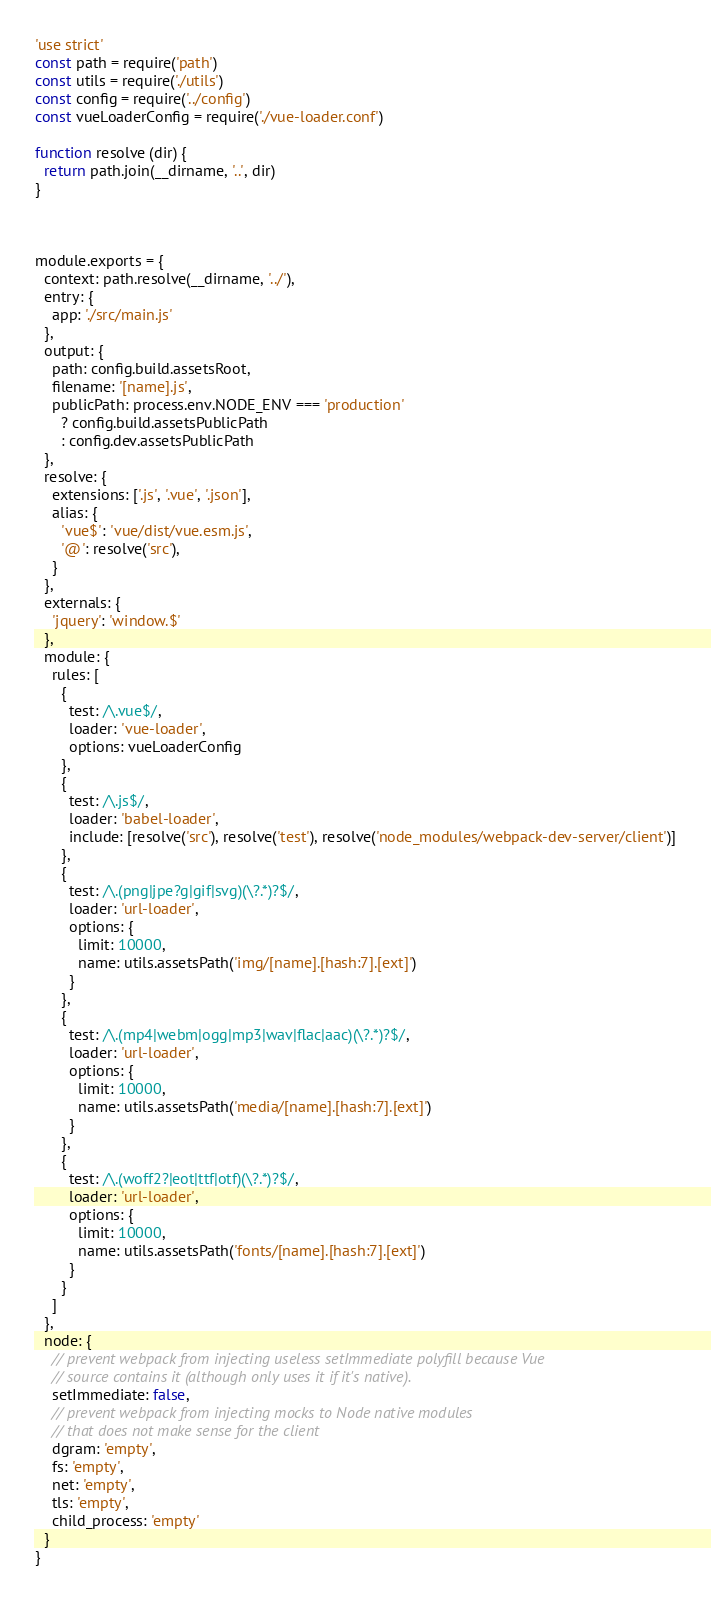Convert code to text. <code><loc_0><loc_0><loc_500><loc_500><_JavaScript_>'use strict'
const path = require('path')
const utils = require('./utils')
const config = require('../config')
const vueLoaderConfig = require('./vue-loader.conf')

function resolve (dir) {
  return path.join(__dirname, '..', dir)
}



module.exports = {
  context: path.resolve(__dirname, '../'),
  entry: {
    app: './src/main.js'
  },
  output: {
    path: config.build.assetsRoot,
    filename: '[name].js',
    publicPath: process.env.NODE_ENV === 'production'
      ? config.build.assetsPublicPath
      : config.dev.assetsPublicPath
  },
  resolve: {
    extensions: ['.js', '.vue', '.json'],
    alias: {
      'vue$': 'vue/dist/vue.esm.js',
      '@': resolve('src'),
    }
  },
  externals: {
    'jquery': 'window.$'
  },
  module: {
    rules: [
      {
        test: /\.vue$/,
        loader: 'vue-loader',
        options: vueLoaderConfig
      },
      {
        test: /\.js$/,
        loader: 'babel-loader',
        include: [resolve('src'), resolve('test'), resolve('node_modules/webpack-dev-server/client')]
      },
      {
        test: /\.(png|jpe?g|gif|svg)(\?.*)?$/,
        loader: 'url-loader',
        options: {
          limit: 10000,
          name: utils.assetsPath('img/[name].[hash:7].[ext]')
        }
      },
      {
        test: /\.(mp4|webm|ogg|mp3|wav|flac|aac)(\?.*)?$/,
        loader: 'url-loader',
        options: {
          limit: 10000,
          name: utils.assetsPath('media/[name].[hash:7].[ext]')
        }
      },
      {
        test: /\.(woff2?|eot|ttf|otf)(\?.*)?$/,
        loader: 'url-loader',
        options: {
          limit: 10000,
          name: utils.assetsPath('fonts/[name].[hash:7].[ext]')
        }
      }
    ]
  },
  node: {
    // prevent webpack from injecting useless setImmediate polyfill because Vue
    // source contains it (although only uses it if it's native).
    setImmediate: false,
    // prevent webpack from injecting mocks to Node native modules
    // that does not make sense for the client
    dgram: 'empty',
    fs: 'empty',
    net: 'empty',
    tls: 'empty',
    child_process: 'empty'
  }
}
</code> 